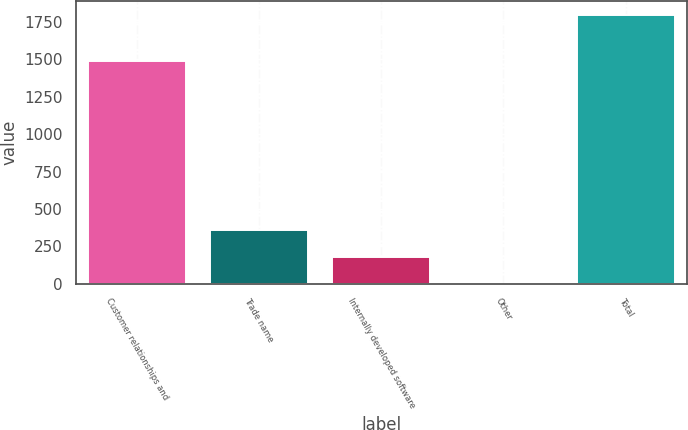Convert chart. <chart><loc_0><loc_0><loc_500><loc_500><bar_chart><fcel>Customer relationships and<fcel>Trade name<fcel>Internally developed software<fcel>Other<fcel>Total<nl><fcel>1490.8<fcel>360.14<fcel>180.47<fcel>0.8<fcel>1797.5<nl></chart> 